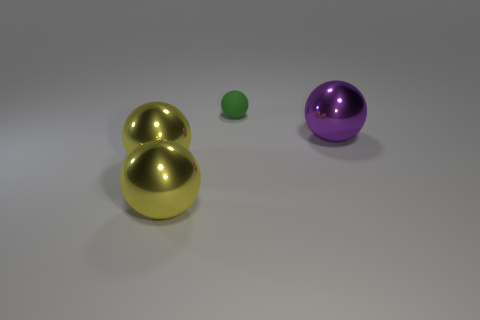Is there a big thing that is on the left side of the metal thing that is to the right of the tiny matte object?
Ensure brevity in your answer.  Yes. There is a object behind the purple sphere; is it the same shape as the thing that is to the right of the small green object?
Ensure brevity in your answer.  Yes. Do the large thing that is on the right side of the rubber sphere and the thing that is behind the large purple metal thing have the same material?
Your answer should be compact. No. The sphere that is right of the thing behind the purple object is made of what material?
Your answer should be very brief. Metal. What material is the purple thing that is the same shape as the green rubber object?
Keep it short and to the point. Metal. What number of large green matte things are there?
Your answer should be very brief. 0. There is a shiny object that is to the right of the small green rubber ball; what shape is it?
Offer a very short reply. Sphere. What color is the thing that is on the right side of the ball behind the big sphere that is right of the rubber object?
Your answer should be very brief. Purple. Is the number of big metallic spheres less than the number of matte balls?
Provide a succinct answer. No. What number of other things are the same color as the matte sphere?
Keep it short and to the point. 0. 